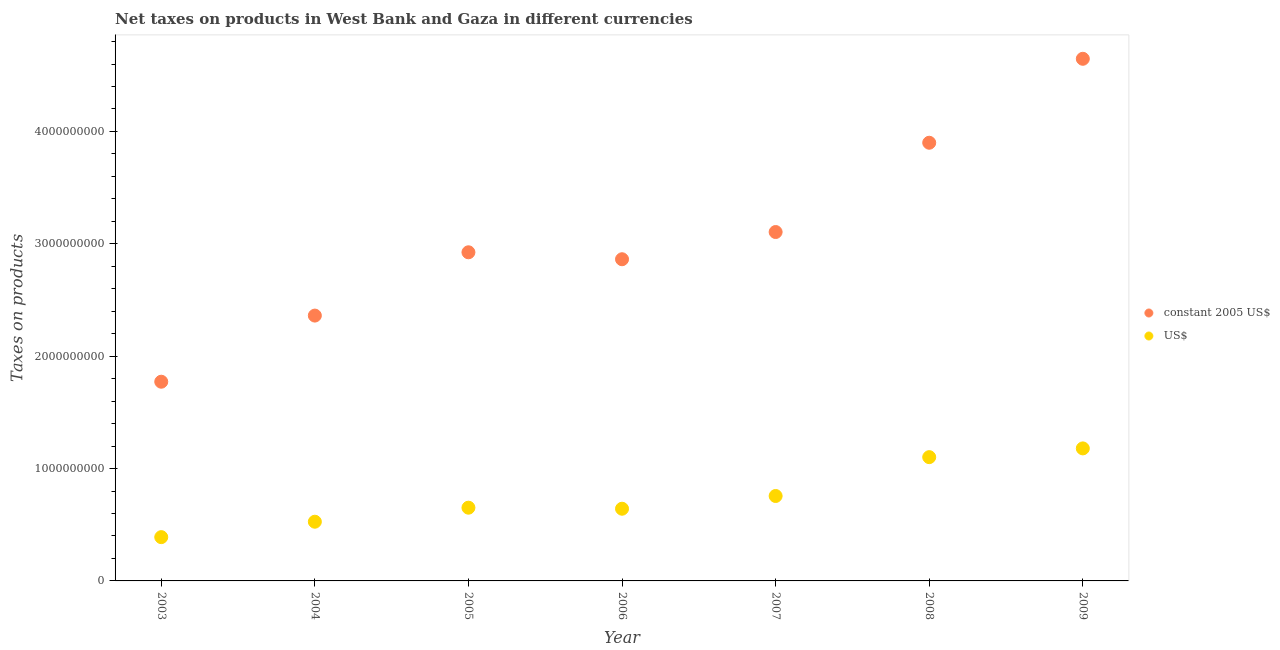Is the number of dotlines equal to the number of legend labels?
Offer a very short reply. Yes. What is the net taxes in us$ in 2004?
Your response must be concise. 5.27e+08. Across all years, what is the maximum net taxes in constant 2005 us$?
Your response must be concise. 4.65e+09. Across all years, what is the minimum net taxes in us$?
Ensure brevity in your answer.  3.90e+08. In which year was the net taxes in constant 2005 us$ maximum?
Your answer should be very brief. 2009. In which year was the net taxes in constant 2005 us$ minimum?
Offer a very short reply. 2003. What is the total net taxes in us$ in the graph?
Your response must be concise. 5.25e+09. What is the difference between the net taxes in us$ in 2008 and that in 2009?
Give a very brief answer. -7.78e+07. What is the difference between the net taxes in constant 2005 us$ in 2007 and the net taxes in us$ in 2005?
Ensure brevity in your answer.  2.45e+09. What is the average net taxes in us$ per year?
Your answer should be compact. 7.50e+08. In the year 2009, what is the difference between the net taxes in constant 2005 us$ and net taxes in us$?
Keep it short and to the point. 3.47e+09. What is the ratio of the net taxes in constant 2005 us$ in 2003 to that in 2008?
Provide a short and direct response. 0.45. What is the difference between the highest and the second highest net taxes in us$?
Your answer should be very brief. 7.78e+07. What is the difference between the highest and the lowest net taxes in constant 2005 us$?
Your answer should be compact. 2.87e+09. Is the sum of the net taxes in constant 2005 us$ in 2003 and 2005 greater than the maximum net taxes in us$ across all years?
Give a very brief answer. Yes. Does the net taxes in us$ monotonically increase over the years?
Offer a terse response. No. Is the net taxes in constant 2005 us$ strictly less than the net taxes in us$ over the years?
Offer a very short reply. No. How many years are there in the graph?
Give a very brief answer. 7. Are the values on the major ticks of Y-axis written in scientific E-notation?
Ensure brevity in your answer.  No. Does the graph contain grids?
Make the answer very short. No. Where does the legend appear in the graph?
Your answer should be very brief. Center right. How many legend labels are there?
Ensure brevity in your answer.  2. What is the title of the graph?
Offer a terse response. Net taxes on products in West Bank and Gaza in different currencies. Does "Borrowers" appear as one of the legend labels in the graph?
Provide a succinct answer. No. What is the label or title of the Y-axis?
Provide a short and direct response. Taxes on products. What is the Taxes on products of constant 2005 US$ in 2003?
Provide a succinct answer. 1.77e+09. What is the Taxes on products of US$ in 2003?
Provide a succinct answer. 3.90e+08. What is the Taxes on products of constant 2005 US$ in 2004?
Provide a short and direct response. 2.36e+09. What is the Taxes on products in US$ in 2004?
Your response must be concise. 5.27e+08. What is the Taxes on products of constant 2005 US$ in 2005?
Your answer should be compact. 2.92e+09. What is the Taxes on products of US$ in 2005?
Make the answer very short. 6.52e+08. What is the Taxes on products of constant 2005 US$ in 2006?
Provide a succinct answer. 2.86e+09. What is the Taxes on products in US$ in 2006?
Make the answer very short. 6.43e+08. What is the Taxes on products of constant 2005 US$ in 2007?
Your answer should be very brief. 3.11e+09. What is the Taxes on products of US$ in 2007?
Offer a terse response. 7.56e+08. What is the Taxes on products of constant 2005 US$ in 2008?
Your answer should be very brief. 3.90e+09. What is the Taxes on products in US$ in 2008?
Provide a short and direct response. 1.10e+09. What is the Taxes on products in constant 2005 US$ in 2009?
Your answer should be very brief. 4.65e+09. What is the Taxes on products in US$ in 2009?
Offer a very short reply. 1.18e+09. Across all years, what is the maximum Taxes on products of constant 2005 US$?
Keep it short and to the point. 4.65e+09. Across all years, what is the maximum Taxes on products of US$?
Offer a very short reply. 1.18e+09. Across all years, what is the minimum Taxes on products of constant 2005 US$?
Keep it short and to the point. 1.77e+09. Across all years, what is the minimum Taxes on products of US$?
Keep it short and to the point. 3.90e+08. What is the total Taxes on products of constant 2005 US$ in the graph?
Your answer should be compact. 2.16e+1. What is the total Taxes on products in US$ in the graph?
Provide a short and direct response. 5.25e+09. What is the difference between the Taxes on products in constant 2005 US$ in 2003 and that in 2004?
Your response must be concise. -5.89e+08. What is the difference between the Taxes on products in US$ in 2003 and that in 2004?
Keep it short and to the point. -1.37e+08. What is the difference between the Taxes on products of constant 2005 US$ in 2003 and that in 2005?
Provide a short and direct response. -1.15e+09. What is the difference between the Taxes on products of US$ in 2003 and that in 2005?
Offer a very short reply. -2.62e+08. What is the difference between the Taxes on products in constant 2005 US$ in 2003 and that in 2006?
Ensure brevity in your answer.  -1.09e+09. What is the difference between the Taxes on products of US$ in 2003 and that in 2006?
Make the answer very short. -2.53e+08. What is the difference between the Taxes on products of constant 2005 US$ in 2003 and that in 2007?
Your answer should be very brief. -1.33e+09. What is the difference between the Taxes on products of US$ in 2003 and that in 2007?
Your answer should be compact. -3.66e+08. What is the difference between the Taxes on products of constant 2005 US$ in 2003 and that in 2008?
Ensure brevity in your answer.  -2.13e+09. What is the difference between the Taxes on products of US$ in 2003 and that in 2008?
Keep it short and to the point. -7.12e+08. What is the difference between the Taxes on products in constant 2005 US$ in 2003 and that in 2009?
Give a very brief answer. -2.87e+09. What is the difference between the Taxes on products of US$ in 2003 and that in 2009?
Offer a terse response. -7.90e+08. What is the difference between the Taxes on products in constant 2005 US$ in 2004 and that in 2005?
Offer a terse response. -5.63e+08. What is the difference between the Taxes on products of US$ in 2004 and that in 2005?
Ensure brevity in your answer.  -1.25e+08. What is the difference between the Taxes on products of constant 2005 US$ in 2004 and that in 2006?
Your answer should be compact. -5.01e+08. What is the difference between the Taxes on products in US$ in 2004 and that in 2006?
Provide a short and direct response. -1.16e+08. What is the difference between the Taxes on products in constant 2005 US$ in 2004 and that in 2007?
Offer a terse response. -7.44e+08. What is the difference between the Taxes on products in US$ in 2004 and that in 2007?
Give a very brief answer. -2.29e+08. What is the difference between the Taxes on products in constant 2005 US$ in 2004 and that in 2008?
Make the answer very short. -1.54e+09. What is the difference between the Taxes on products in US$ in 2004 and that in 2008?
Keep it short and to the point. -5.75e+08. What is the difference between the Taxes on products of constant 2005 US$ in 2004 and that in 2009?
Provide a succinct answer. -2.29e+09. What is the difference between the Taxes on products of US$ in 2004 and that in 2009?
Offer a terse response. -6.53e+08. What is the difference between the Taxes on products of constant 2005 US$ in 2005 and that in 2006?
Ensure brevity in your answer.  6.19e+07. What is the difference between the Taxes on products of US$ in 2005 and that in 2006?
Provide a short and direct response. 9.23e+06. What is the difference between the Taxes on products in constant 2005 US$ in 2005 and that in 2007?
Your answer should be compact. -1.80e+08. What is the difference between the Taxes on products in US$ in 2005 and that in 2007?
Your response must be concise. -1.04e+08. What is the difference between the Taxes on products in constant 2005 US$ in 2005 and that in 2008?
Ensure brevity in your answer.  -9.75e+08. What is the difference between the Taxes on products in US$ in 2005 and that in 2008?
Offer a terse response. -4.50e+08. What is the difference between the Taxes on products in constant 2005 US$ in 2005 and that in 2009?
Keep it short and to the point. -1.72e+09. What is the difference between the Taxes on products in US$ in 2005 and that in 2009?
Provide a short and direct response. -5.28e+08. What is the difference between the Taxes on products of constant 2005 US$ in 2006 and that in 2007?
Offer a very short reply. -2.42e+08. What is the difference between the Taxes on products of US$ in 2006 and that in 2007?
Keep it short and to the point. -1.13e+08. What is the difference between the Taxes on products in constant 2005 US$ in 2006 and that in 2008?
Keep it short and to the point. -1.04e+09. What is the difference between the Taxes on products of US$ in 2006 and that in 2008?
Make the answer very short. -4.59e+08. What is the difference between the Taxes on products in constant 2005 US$ in 2006 and that in 2009?
Provide a succinct answer. -1.78e+09. What is the difference between the Taxes on products of US$ in 2006 and that in 2009?
Ensure brevity in your answer.  -5.37e+08. What is the difference between the Taxes on products of constant 2005 US$ in 2007 and that in 2008?
Ensure brevity in your answer.  -7.95e+08. What is the difference between the Taxes on products of US$ in 2007 and that in 2008?
Ensure brevity in your answer.  -3.46e+08. What is the difference between the Taxes on products of constant 2005 US$ in 2007 and that in 2009?
Your answer should be very brief. -1.54e+09. What is the difference between the Taxes on products of US$ in 2007 and that in 2009?
Ensure brevity in your answer.  -4.24e+08. What is the difference between the Taxes on products in constant 2005 US$ in 2008 and that in 2009?
Offer a very short reply. -7.47e+08. What is the difference between the Taxes on products of US$ in 2008 and that in 2009?
Your answer should be compact. -7.78e+07. What is the difference between the Taxes on products in constant 2005 US$ in 2003 and the Taxes on products in US$ in 2004?
Provide a succinct answer. 1.25e+09. What is the difference between the Taxes on products in constant 2005 US$ in 2003 and the Taxes on products in US$ in 2005?
Provide a succinct answer. 1.12e+09. What is the difference between the Taxes on products in constant 2005 US$ in 2003 and the Taxes on products in US$ in 2006?
Your answer should be compact. 1.13e+09. What is the difference between the Taxes on products of constant 2005 US$ in 2003 and the Taxes on products of US$ in 2007?
Provide a short and direct response. 1.02e+09. What is the difference between the Taxes on products of constant 2005 US$ in 2003 and the Taxes on products of US$ in 2008?
Provide a short and direct response. 6.71e+08. What is the difference between the Taxes on products of constant 2005 US$ in 2003 and the Taxes on products of US$ in 2009?
Give a very brief answer. 5.93e+08. What is the difference between the Taxes on products in constant 2005 US$ in 2004 and the Taxes on products in US$ in 2005?
Provide a short and direct response. 1.71e+09. What is the difference between the Taxes on products of constant 2005 US$ in 2004 and the Taxes on products of US$ in 2006?
Give a very brief answer. 1.72e+09. What is the difference between the Taxes on products of constant 2005 US$ in 2004 and the Taxes on products of US$ in 2007?
Your answer should be compact. 1.61e+09. What is the difference between the Taxes on products in constant 2005 US$ in 2004 and the Taxes on products in US$ in 2008?
Your response must be concise. 1.26e+09. What is the difference between the Taxes on products in constant 2005 US$ in 2004 and the Taxes on products in US$ in 2009?
Offer a very short reply. 1.18e+09. What is the difference between the Taxes on products of constant 2005 US$ in 2005 and the Taxes on products of US$ in 2006?
Provide a short and direct response. 2.28e+09. What is the difference between the Taxes on products of constant 2005 US$ in 2005 and the Taxes on products of US$ in 2007?
Your response must be concise. 2.17e+09. What is the difference between the Taxes on products of constant 2005 US$ in 2005 and the Taxes on products of US$ in 2008?
Your answer should be very brief. 1.82e+09. What is the difference between the Taxes on products in constant 2005 US$ in 2005 and the Taxes on products in US$ in 2009?
Your answer should be compact. 1.75e+09. What is the difference between the Taxes on products in constant 2005 US$ in 2006 and the Taxes on products in US$ in 2007?
Provide a succinct answer. 2.11e+09. What is the difference between the Taxes on products in constant 2005 US$ in 2006 and the Taxes on products in US$ in 2008?
Give a very brief answer. 1.76e+09. What is the difference between the Taxes on products of constant 2005 US$ in 2006 and the Taxes on products of US$ in 2009?
Provide a short and direct response. 1.68e+09. What is the difference between the Taxes on products in constant 2005 US$ in 2007 and the Taxes on products in US$ in 2008?
Provide a short and direct response. 2.00e+09. What is the difference between the Taxes on products in constant 2005 US$ in 2007 and the Taxes on products in US$ in 2009?
Provide a short and direct response. 1.93e+09. What is the difference between the Taxes on products in constant 2005 US$ in 2008 and the Taxes on products in US$ in 2009?
Keep it short and to the point. 2.72e+09. What is the average Taxes on products in constant 2005 US$ per year?
Make the answer very short. 3.08e+09. What is the average Taxes on products in US$ per year?
Your answer should be compact. 7.50e+08. In the year 2003, what is the difference between the Taxes on products of constant 2005 US$ and Taxes on products of US$?
Provide a succinct answer. 1.38e+09. In the year 2004, what is the difference between the Taxes on products in constant 2005 US$ and Taxes on products in US$?
Offer a terse response. 1.83e+09. In the year 2005, what is the difference between the Taxes on products in constant 2005 US$ and Taxes on products in US$?
Ensure brevity in your answer.  2.27e+09. In the year 2006, what is the difference between the Taxes on products of constant 2005 US$ and Taxes on products of US$?
Keep it short and to the point. 2.22e+09. In the year 2007, what is the difference between the Taxes on products of constant 2005 US$ and Taxes on products of US$?
Provide a short and direct response. 2.35e+09. In the year 2008, what is the difference between the Taxes on products in constant 2005 US$ and Taxes on products in US$?
Your answer should be compact. 2.80e+09. In the year 2009, what is the difference between the Taxes on products in constant 2005 US$ and Taxes on products in US$?
Give a very brief answer. 3.47e+09. What is the ratio of the Taxes on products in constant 2005 US$ in 2003 to that in 2004?
Offer a terse response. 0.75. What is the ratio of the Taxes on products of US$ in 2003 to that in 2004?
Provide a succinct answer. 0.74. What is the ratio of the Taxes on products in constant 2005 US$ in 2003 to that in 2005?
Your answer should be very brief. 0.61. What is the ratio of the Taxes on products in US$ in 2003 to that in 2005?
Give a very brief answer. 0.6. What is the ratio of the Taxes on products of constant 2005 US$ in 2003 to that in 2006?
Your answer should be compact. 0.62. What is the ratio of the Taxes on products in US$ in 2003 to that in 2006?
Keep it short and to the point. 0.61. What is the ratio of the Taxes on products in constant 2005 US$ in 2003 to that in 2007?
Keep it short and to the point. 0.57. What is the ratio of the Taxes on products of US$ in 2003 to that in 2007?
Give a very brief answer. 0.52. What is the ratio of the Taxes on products of constant 2005 US$ in 2003 to that in 2008?
Provide a short and direct response. 0.45. What is the ratio of the Taxes on products of US$ in 2003 to that in 2008?
Your answer should be compact. 0.35. What is the ratio of the Taxes on products of constant 2005 US$ in 2003 to that in 2009?
Give a very brief answer. 0.38. What is the ratio of the Taxes on products in US$ in 2003 to that in 2009?
Give a very brief answer. 0.33. What is the ratio of the Taxes on products of constant 2005 US$ in 2004 to that in 2005?
Offer a terse response. 0.81. What is the ratio of the Taxes on products in US$ in 2004 to that in 2005?
Give a very brief answer. 0.81. What is the ratio of the Taxes on products of constant 2005 US$ in 2004 to that in 2006?
Offer a terse response. 0.82. What is the ratio of the Taxes on products in US$ in 2004 to that in 2006?
Offer a very short reply. 0.82. What is the ratio of the Taxes on products in constant 2005 US$ in 2004 to that in 2007?
Offer a terse response. 0.76. What is the ratio of the Taxes on products of US$ in 2004 to that in 2007?
Offer a terse response. 0.7. What is the ratio of the Taxes on products in constant 2005 US$ in 2004 to that in 2008?
Ensure brevity in your answer.  0.61. What is the ratio of the Taxes on products of US$ in 2004 to that in 2008?
Ensure brevity in your answer.  0.48. What is the ratio of the Taxes on products in constant 2005 US$ in 2004 to that in 2009?
Offer a terse response. 0.51. What is the ratio of the Taxes on products of US$ in 2004 to that in 2009?
Make the answer very short. 0.45. What is the ratio of the Taxes on products of constant 2005 US$ in 2005 to that in 2006?
Offer a terse response. 1.02. What is the ratio of the Taxes on products of US$ in 2005 to that in 2006?
Make the answer very short. 1.01. What is the ratio of the Taxes on products of constant 2005 US$ in 2005 to that in 2007?
Give a very brief answer. 0.94. What is the ratio of the Taxes on products in US$ in 2005 to that in 2007?
Ensure brevity in your answer.  0.86. What is the ratio of the Taxes on products in constant 2005 US$ in 2005 to that in 2008?
Ensure brevity in your answer.  0.75. What is the ratio of the Taxes on products of US$ in 2005 to that in 2008?
Ensure brevity in your answer.  0.59. What is the ratio of the Taxes on products of constant 2005 US$ in 2005 to that in 2009?
Make the answer very short. 0.63. What is the ratio of the Taxes on products of US$ in 2005 to that in 2009?
Offer a very short reply. 0.55. What is the ratio of the Taxes on products of constant 2005 US$ in 2006 to that in 2007?
Your answer should be compact. 0.92. What is the ratio of the Taxes on products in US$ in 2006 to that in 2007?
Ensure brevity in your answer.  0.85. What is the ratio of the Taxes on products in constant 2005 US$ in 2006 to that in 2008?
Keep it short and to the point. 0.73. What is the ratio of the Taxes on products of US$ in 2006 to that in 2008?
Give a very brief answer. 0.58. What is the ratio of the Taxes on products of constant 2005 US$ in 2006 to that in 2009?
Offer a terse response. 0.62. What is the ratio of the Taxes on products in US$ in 2006 to that in 2009?
Provide a short and direct response. 0.54. What is the ratio of the Taxes on products in constant 2005 US$ in 2007 to that in 2008?
Provide a succinct answer. 0.8. What is the ratio of the Taxes on products of US$ in 2007 to that in 2008?
Offer a terse response. 0.69. What is the ratio of the Taxes on products of constant 2005 US$ in 2007 to that in 2009?
Give a very brief answer. 0.67. What is the ratio of the Taxes on products in US$ in 2007 to that in 2009?
Give a very brief answer. 0.64. What is the ratio of the Taxes on products of constant 2005 US$ in 2008 to that in 2009?
Offer a terse response. 0.84. What is the ratio of the Taxes on products in US$ in 2008 to that in 2009?
Your answer should be compact. 0.93. What is the difference between the highest and the second highest Taxes on products in constant 2005 US$?
Ensure brevity in your answer.  7.47e+08. What is the difference between the highest and the second highest Taxes on products in US$?
Your answer should be compact. 7.78e+07. What is the difference between the highest and the lowest Taxes on products in constant 2005 US$?
Offer a terse response. 2.87e+09. What is the difference between the highest and the lowest Taxes on products of US$?
Give a very brief answer. 7.90e+08. 